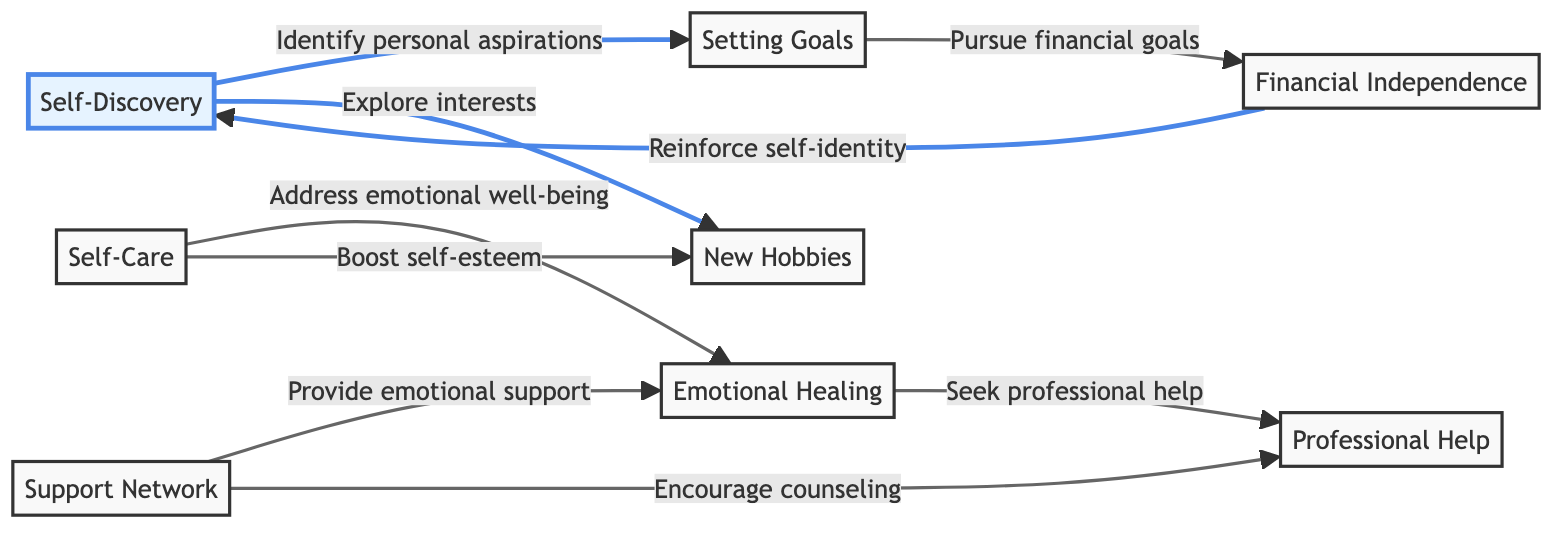What is the first step in rebuilding self-identity? The diagram starts with "Self-Discovery" as the first step in rebuilding self-identity. This is the initial node that lays the foundation for the subsequent actions.
Answer: Self-Discovery How many nodes are in the diagram? Counting all unique points represented in the diagram, there are 8 nodes: Self-Discovery, Support Network, Setting Goals, Self-Care, New Hobbies, Emotional Healing, Professional Help, and Financial Independence.
Answer: 8 Which node is connected to Emotional Healing? Emotional Healing is connected to two nodes: "Support Network" (for providing emotional support) and "Self-Care" (addressing emotional well-being).
Answer: Support Network, Self-Care What type of network does Financial Independence reinforce? Financial Independence reinforces "Self-Identity," indicating that achieving financial stability is linked to rebuilding one’s self-perception following a divorce.
Answer: Self-Identity Which two nodes are directly related to Self-Care? Self-Care is directly related to "Emotional Healing" (addressing emotional well-being) and "New Hobbies" (boosting self-esteem). Therefore, the two directly connected nodes are Emotional Healing and New Hobbies.
Answer: Emotional Healing, New Hobbies What does the Support Network encourage? The Support Network encourages two critical paths: "Counseling" (seeking therapy) and "Emotional Support." Both are mechanisms of assistance designed to help individuals heal emotionally.
Answer: Counseling What outcome is associated with setting financial goals? Setting financial goals is linked to pursuing "Financial Independence," which implies that establishing financial targets is a step towards achieving independence after divorce.
Answer: Financial Independence What should one seek for professional help? The diagram indicates that one should "Seek Professional Help" as a part of the Emotional Healing process, thereby associating professional assistance with healing.
Answer: Seek Professional Help 